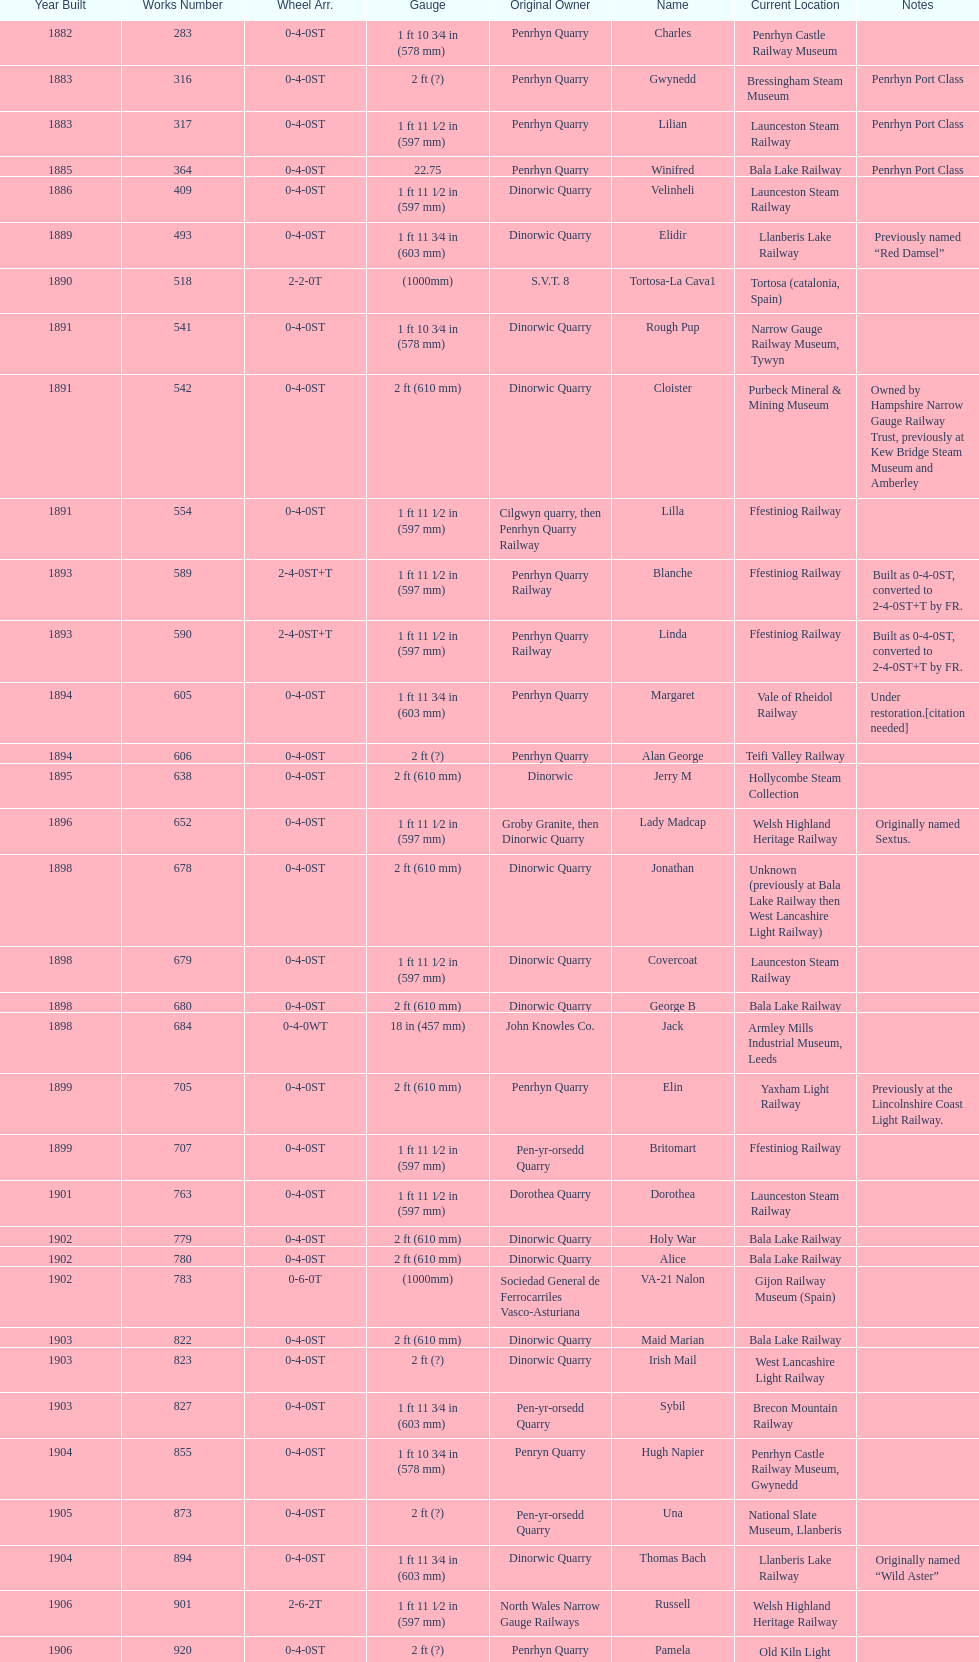To whom did the last locomotive to be built belong? Trangkil Sugar Mill, Indonesia. 